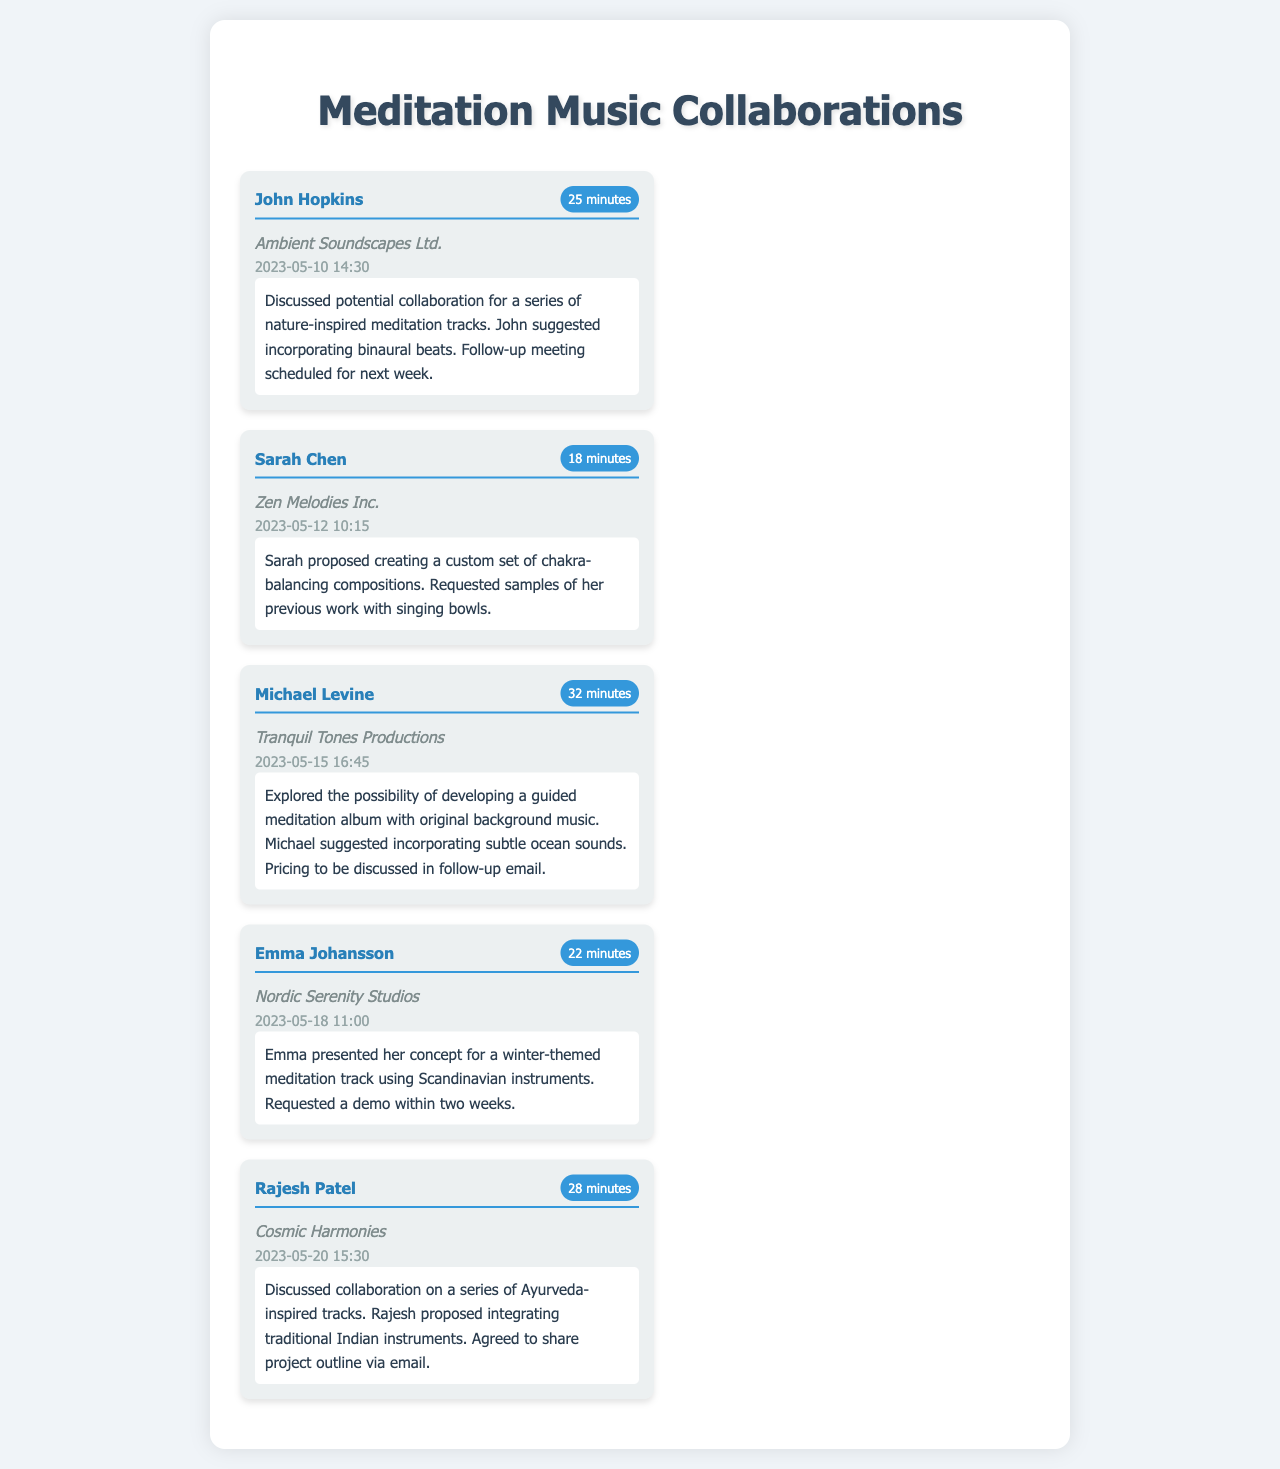What is the name of the composer who suggested binaural beats? John Hopkins suggested incorporating binaural beats during the call about nature-inspired meditation tracks.
Answer: John Hopkins When was the call with Sarah Chen? The call took place on May 12, 2023, at 10:15.
Answer: 2023-05-12 10:15 How long did the conversation with Michael Levine last? The duration of the call with Michael Levine was noted as 32 minutes.
Answer: 32 minutes What type of meditation track did Emma Johansson present? Emma presented a concept for a winter-themed meditation track using Scandinavian instruments.
Answer: Winter-themed Who proposed creating Ayurveda-inspired tracks? Rajesh Patel discussed collaboration on a series of Ayurveda-inspired tracks.
Answer: Rajesh Patel Which company is associated with John Hopkins? The company that John Hopkins is associated with is Ambient Soundscapes Ltd.
Answer: Ambient Soundscapes Ltd What was requested from Sarah Chen during the call? Sarah requested samples of her previous work with singing bowls.
Answer: Samples of previous work What is the follow-up action after the call with Michael Levine? The follow-up action involves discussing pricing in a follow-up email.
Answer: Follow-up email What instrument category was suggested by Rajesh Patel? Rajesh proposed integrating traditional Indian instruments in the meditation tracks.
Answer: Traditional Indian instruments 